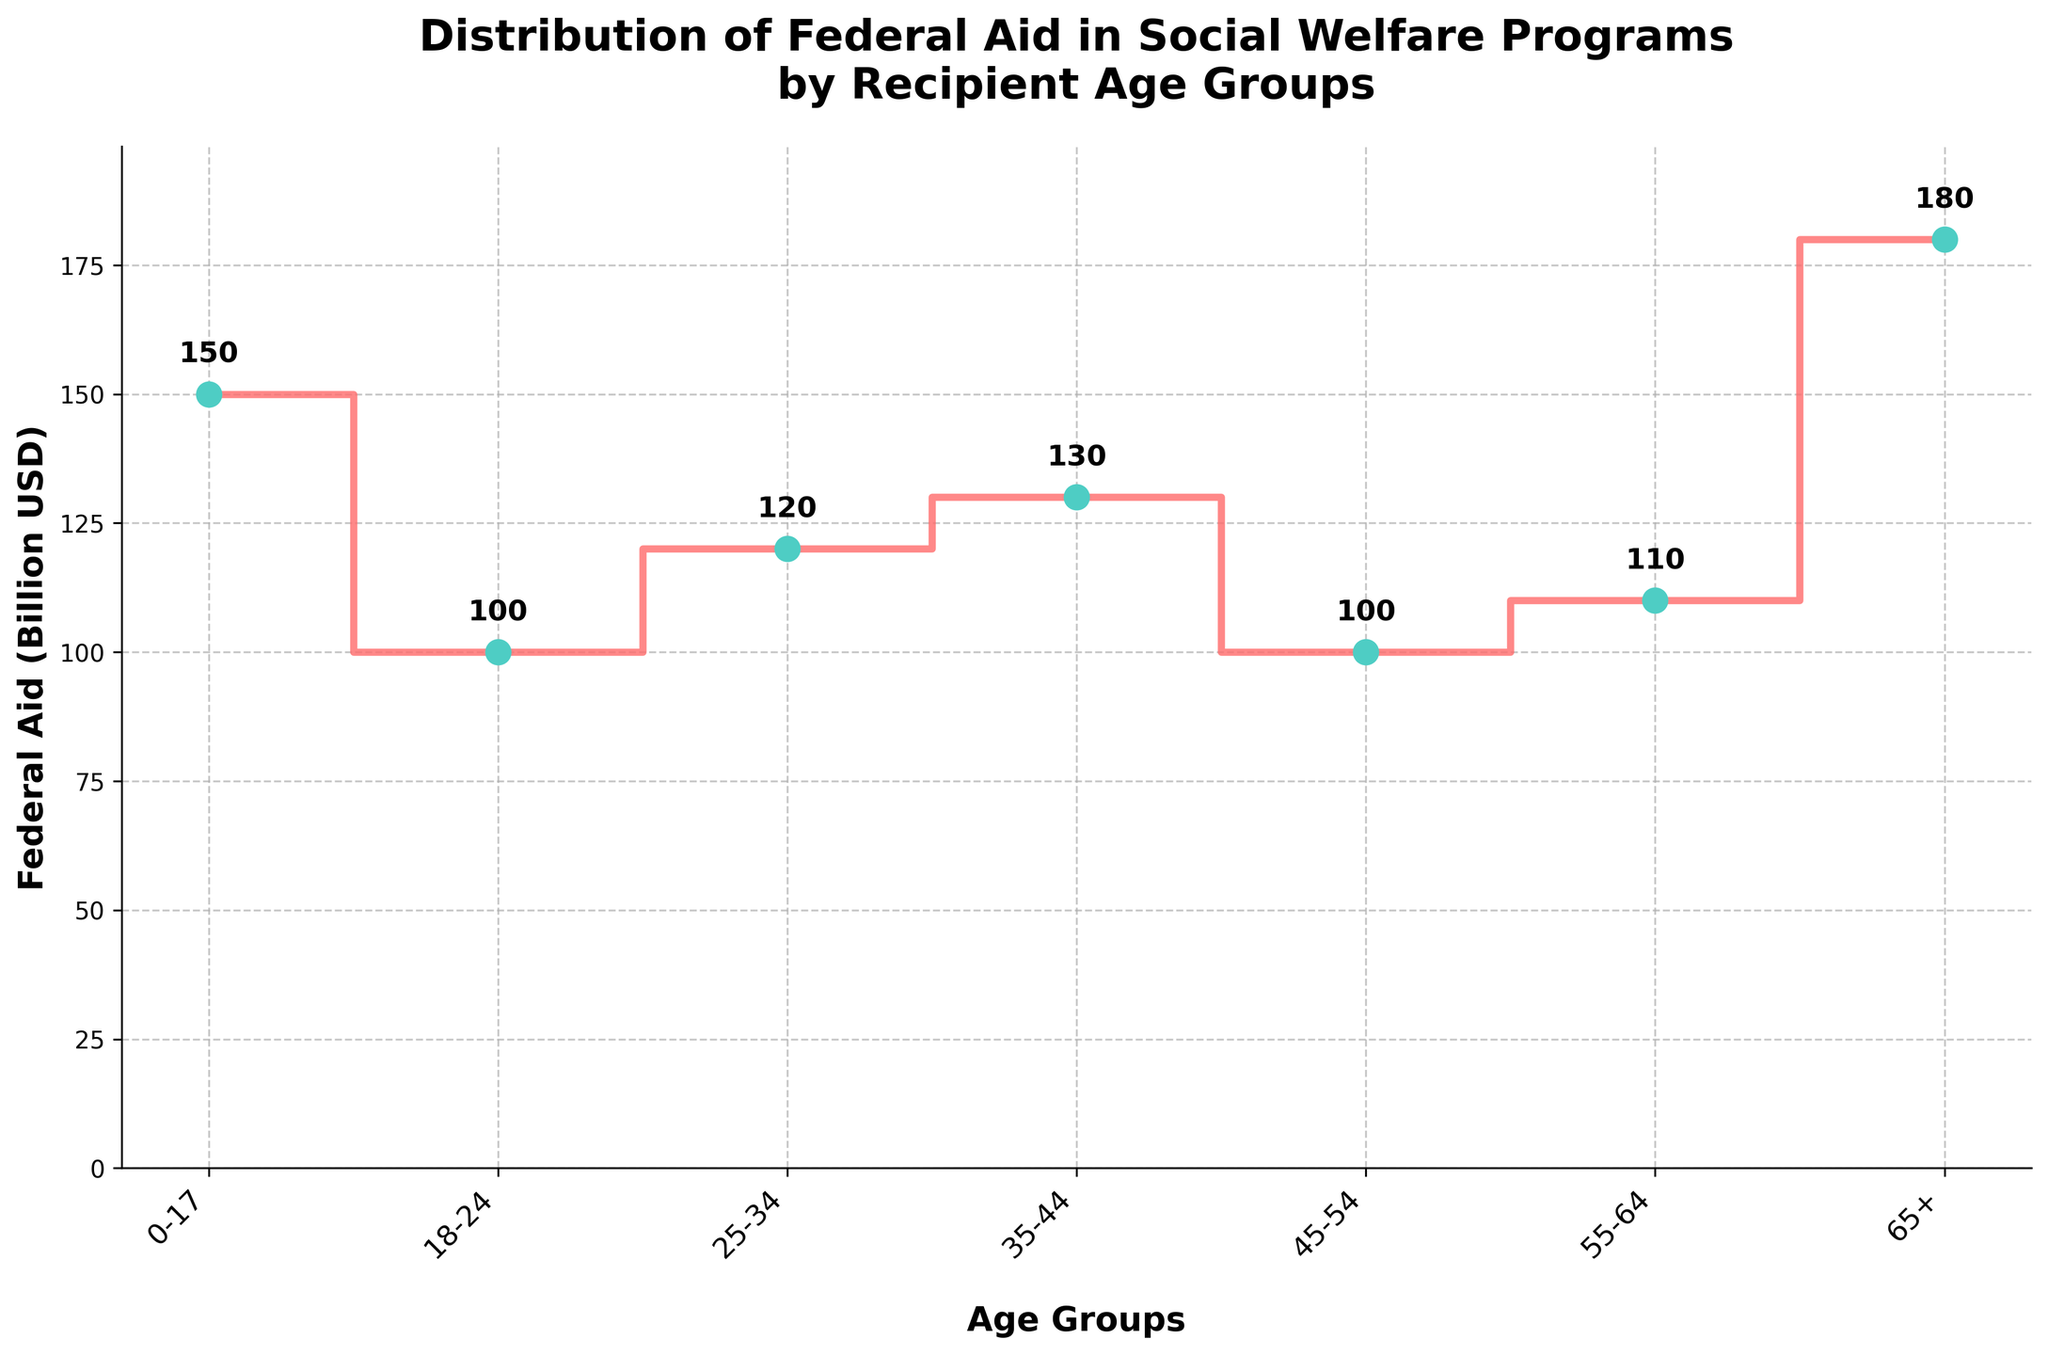What's the title of the figure? The title is prominently displayed at the top of the figure. It reads, "Distribution of Federal Aid in Social Welfare Programs by Recipient Age Groups."
Answer: Distribution of Federal Aid in Social Welfare Programs by Recipient Age Groups What are the age groups included in the figure? The age groups are listed on the x-axis and include "0-17," "18-24," "25-34," "35-44," "45-54," "55-64," and "65+."
Answer: 0-17, 18-24, 25-34, 35-44, 45-54, 55-64, 65+ Which age group receives the highest amount of federal aid? To find the age group with the highest federal aid, we look for the highest point on the y-axis. The "65+" age group, at 180 billion USD, receives the highest aid.
Answer: 65+ Which age group receives the lowest amount of federal aid? By identifying the lowest point on the y-axis, the age group "18-24," with 100 billion USD, receives the lowest aid.
Answer: 18-24 What is the federal aid allocated to the age group "25-34"? The age group "25-34" is marked on the x-axis, and looking up to the data point, it receives 120 billion USD in federal aid.
Answer: 120 billion USD What is the average federal aid across all age groups? To find the average, sum up all the federal aid values (150 + 100 + 120 + 130 + 100 + 110 + 180) = 890 billion USD. Then, divide by the number of age groups (7). The average is 890 / 7 ≈ 127.14 billion USD.
Answer: 127.14 billion USD How much more federal aid does the "65+" age group receive compared to the "18-24" group? Subtract the aid value for "18-24" (100 billion USD) from the "65+" (180 billion USD). So, 180 - 100 = 80 billion USD more aid is received by the "65+" age group.
Answer: 80 billion USD By how much does federal aid increase from the "0-17" age group to the "65+" age group? Subtract the aid value for "0-17" (150 billion USD) from the "65+" (180 billion USD). So, 180 - 150 = 30 billion USD of increase.
Answer: 30 billion USD What is the total amount of federal aid distributed across all age groups? Sum the federal aid values for all age groups: 150 + 100 + 120 + 130 + 100 + 110 + 180 = 890 billion USD.
Answer: 890 billion USD At which age group is the change in federal aid the steepest when moving from one group to the next? By examining the steps in the plot, the change is steepest between "55-64" (110 billion USD) and "65+" (180 billion USD). The difference is 70 billion USD, which is the steepest increase.
Answer: 55-64 to 65+ 